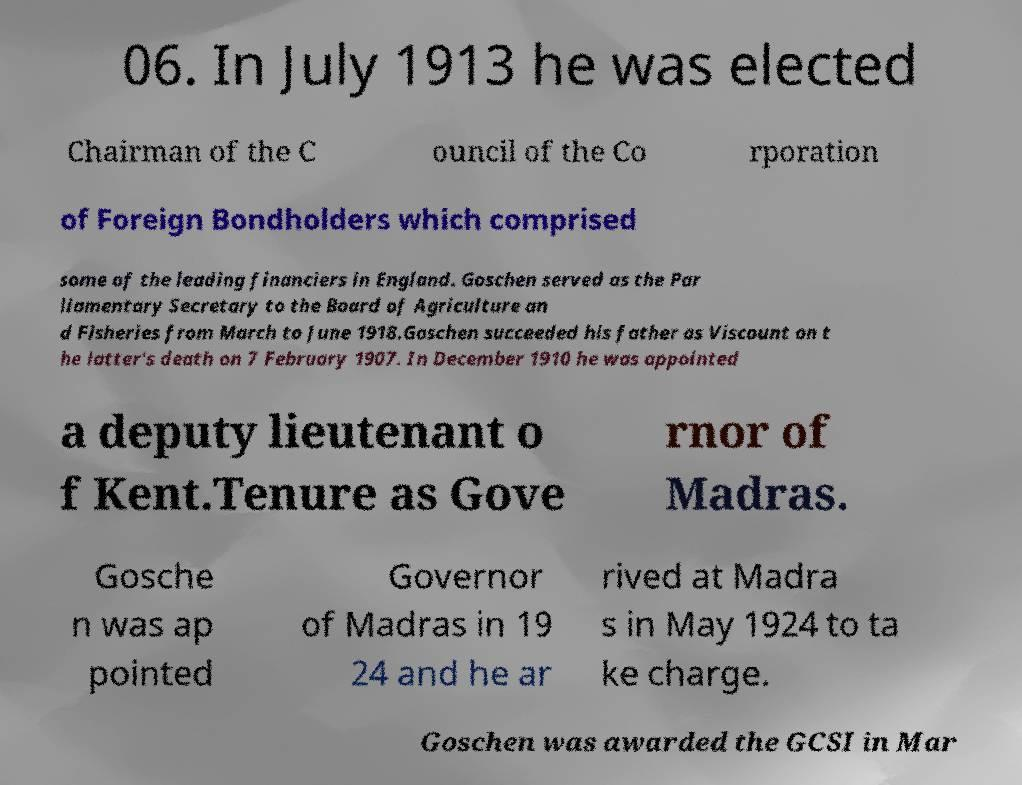Please read and relay the text visible in this image. What does it say? 06. In July 1913 he was elected Chairman of the C ouncil of the Co rporation of Foreign Bondholders which comprised some of the leading financiers in England. Goschen served as the Par liamentary Secretary to the Board of Agriculture an d Fisheries from March to June 1918.Goschen succeeded his father as Viscount on t he latter's death on 7 February 1907. In December 1910 he was appointed a deputy lieutenant o f Kent.Tenure as Gove rnor of Madras. Gosche n was ap pointed Governor of Madras in 19 24 and he ar rived at Madra s in May 1924 to ta ke charge. Goschen was awarded the GCSI in Mar 